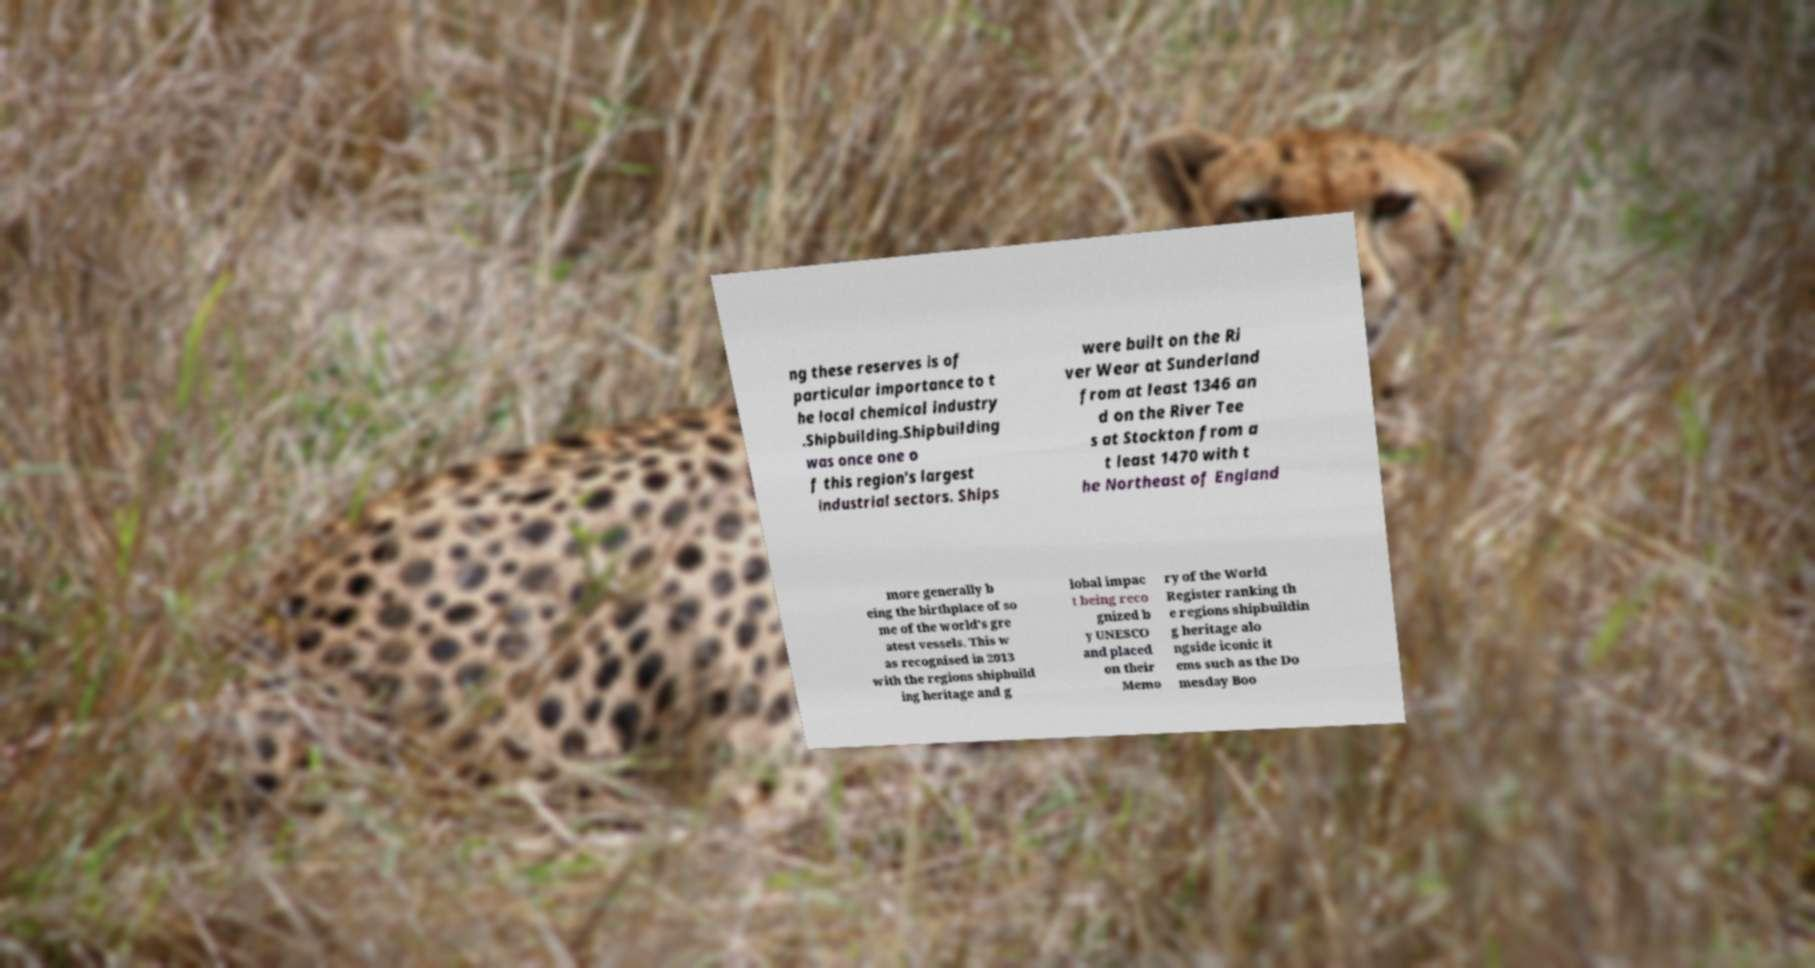There's text embedded in this image that I need extracted. Can you transcribe it verbatim? ng these reserves is of particular importance to t he local chemical industry .Shipbuilding.Shipbuilding was once one o f this region's largest industrial sectors. Ships were built on the Ri ver Wear at Sunderland from at least 1346 an d on the River Tee s at Stockton from a t least 1470 with t he Northeast of England more generally b eing the birthplace of so me of the world's gre atest vessels. This w as recognised in 2013 with the regions shipbuild ing heritage and g lobal impac t being reco gnized b y UNESCO and placed on their Memo ry of the World Register ranking th e regions shipbuildin g heritage alo ngside iconic it ems such as the Do mesday Boo 